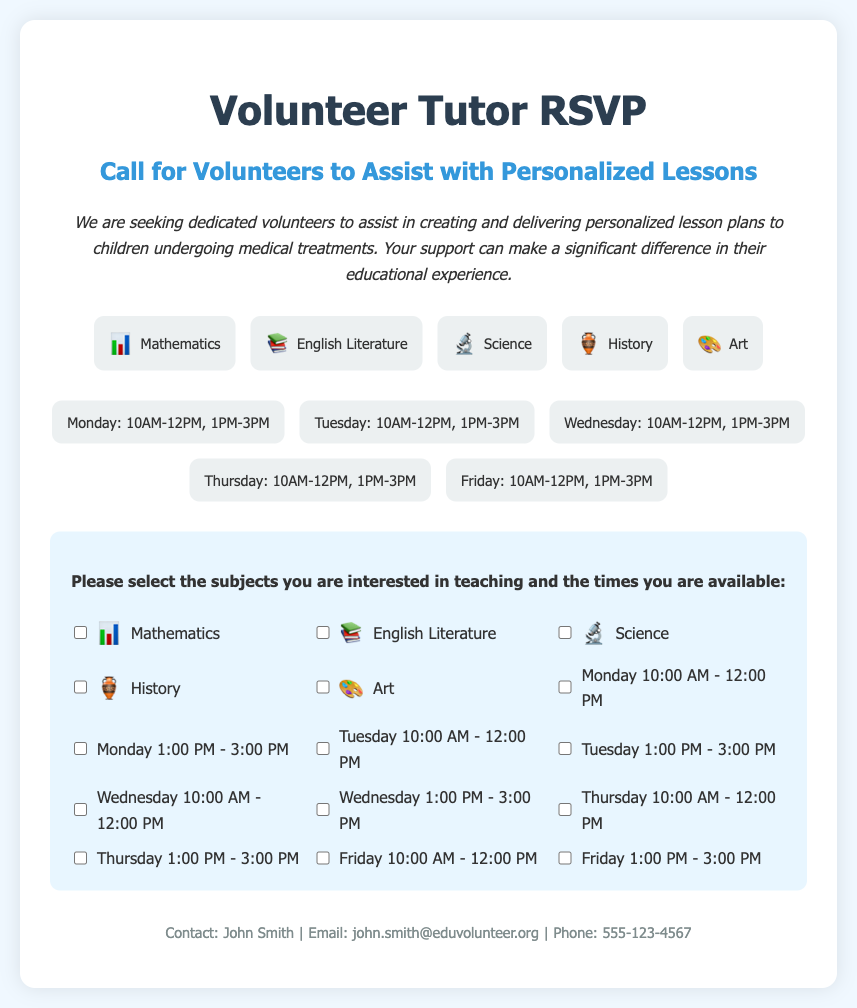What is the title of the document? The title is prominently displayed at the top of the document.
Answer: Volunteer Tutor RSVP What subjects are listed for tutoring? The subjects are detailed in the subjects section of the document.
Answer: Mathematics, English Literature, Science, History, Art What day is available from 10AM-12PM? The available times for tutoring are listed under the times section.
Answer: Every weekday How many time slots are available on Friday? The times section indicates how many options are available on that day.
Answer: Two Who can be contacted for more information? The contact information is provided at the bottom of the document.
Answer: John Smith What is the main purpose of this RSVP card? The introduction outlines the goal of the request for volunteers.
Answer: To assist with personalized lessons How many total subjects can volunteers opt-in to teach? The document lists the subjects available for volunteering.
Answer: Five Which icon represents English Literature? The icons are shown with each subject in the subjects section.
Answer: 📚 